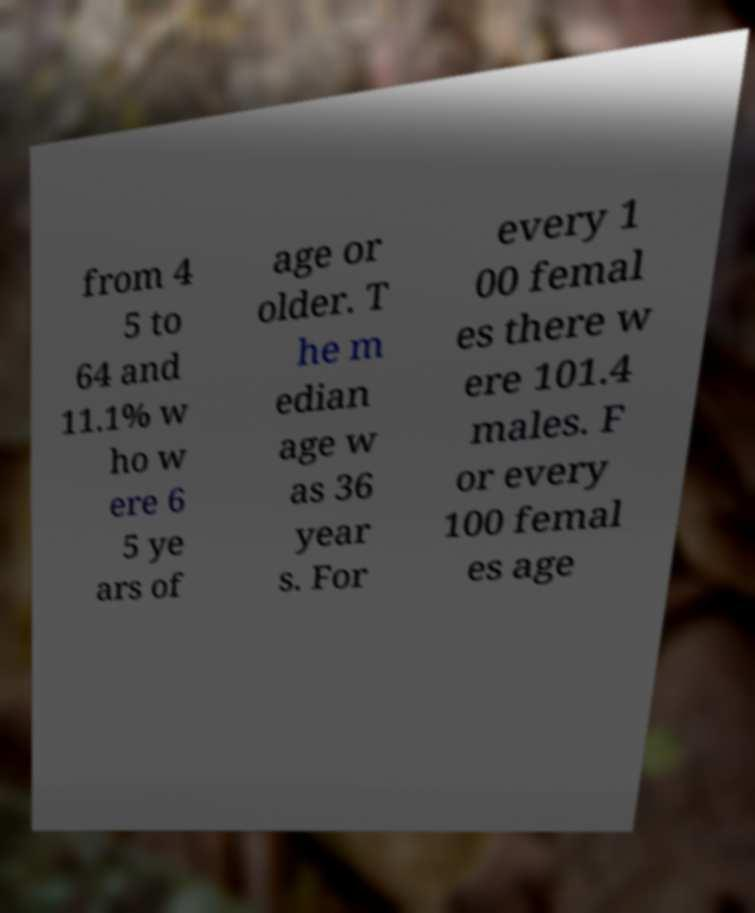There's text embedded in this image that I need extracted. Can you transcribe it verbatim? from 4 5 to 64 and 11.1% w ho w ere 6 5 ye ars of age or older. T he m edian age w as 36 year s. For every 1 00 femal es there w ere 101.4 males. F or every 100 femal es age 